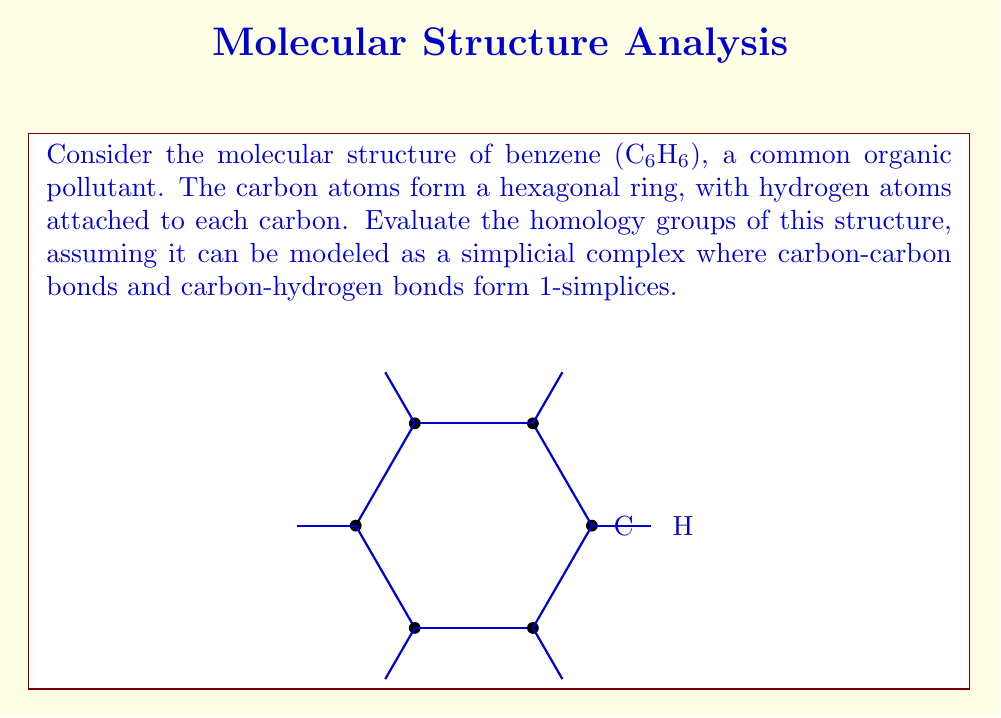Give your solution to this math problem. To evaluate the homology groups of the benzene structure, we'll follow these steps:

1) First, let's count the simplices:
   - 0-simplices (vertices): 12 (6 carbon atoms + 6 hydrogen atoms)
   - 1-simplices (edges): 12 (6 C-C bonds + 6 C-H bonds)
   - No higher-dimensional simplices

2) Now, let's calculate the chain groups:
   $$C_0 = \mathbb{Z}^{12}, C_1 = \mathbb{Z}^{12}, C_k = 0 \text{ for } k \geq 2$$

3) Next, we need to determine the boundary maps:
   $$\partial_1: C_1 \to C_0, \partial_k = 0 \text{ for } k \geq 2$$

4) Calculate the kernel and image of these maps:
   - $\ker(\partial_1)$ is the cycle group $Z_1$, which has rank 1 (the hexagonal cycle)
   - $\text{im}(\partial_1)$ has rank 11 (connects 11 out of 12 vertices)
   - $\ker(\partial_0) = C_0$ (rank 12)

5) Now we can calculate the homology groups:
   - $H_0 = \ker(\partial_0) / \text{im}(\partial_1) \cong \mathbb{Z}$ (connected component)
   - $H_1 = \ker(\partial_1) / \text{im}(\partial_2) \cong \mathbb{Z}$ (one loop)
   - $H_k = 0 \text{ for } k \geq 2$ (no higher-dimensional holes)
Answer: $H_0 \cong \mathbb{Z}, H_1 \cong \mathbb{Z}, H_k \cong 0 \text{ for } k \geq 2$ 